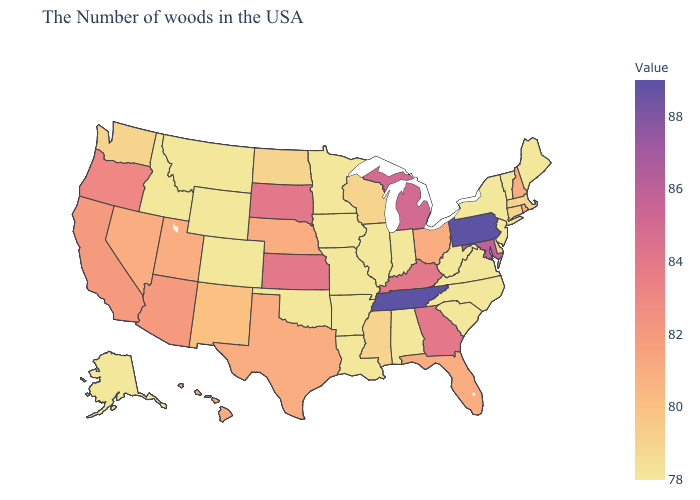Does Mississippi have a higher value than Tennessee?
Give a very brief answer. No. Does Nevada have a lower value than Massachusetts?
Concise answer only. No. Which states hav the highest value in the West?
Write a very short answer. Oregon. Which states have the lowest value in the West?
Quick response, please. Wyoming, Colorado, Montana, Idaho, Alaska. Is the legend a continuous bar?
Concise answer only. Yes. Does Florida have a higher value than Tennessee?
Write a very short answer. No. 